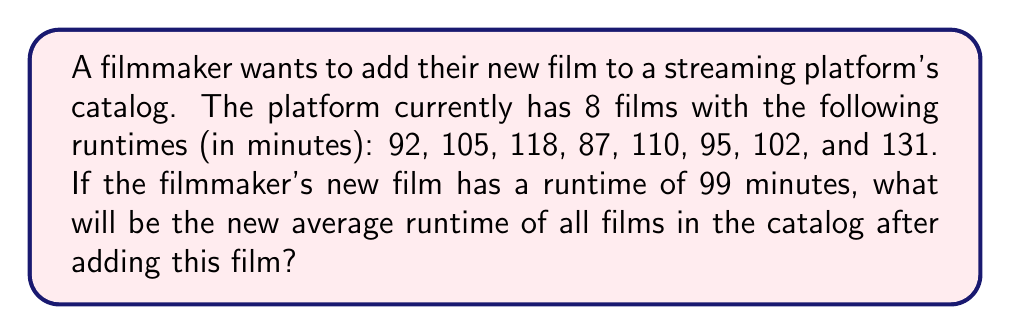Can you answer this question? To solve this problem, we'll follow these steps:

1. Calculate the sum of the existing film runtimes:
   $92 + 105 + 118 + 87 + 110 + 95 + 102 + 131 = 840$ minutes

2. Add the new film's runtime to the sum:
   $840 + 99 = 939$ minutes

3. Count the total number of films after adding the new one:
   $8 + 1 = 9$ films

4. Calculate the new average runtime using the formula:
   $$\text{Average} = \frac{\text{Sum of all runtimes}}{\text{Number of films}}$$

   $$\text{Average} = \frac{939}{9} = 104.33\overline{3}$$ minutes

Therefore, the new average runtime of all films in the catalog after adding the filmmaker's new film will be approximately 104.33 minutes.
Answer: $104.33$ minutes (rounded to two decimal places) 